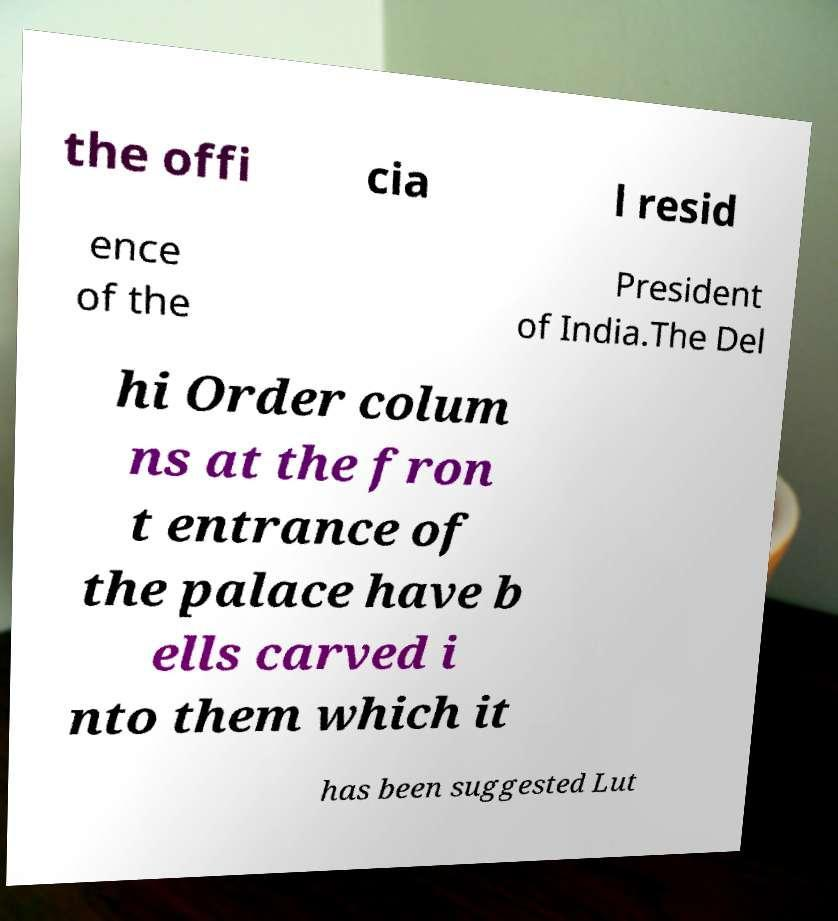Can you accurately transcribe the text from the provided image for me? the offi cia l resid ence of the President of India.The Del hi Order colum ns at the fron t entrance of the palace have b ells carved i nto them which it has been suggested Lut 